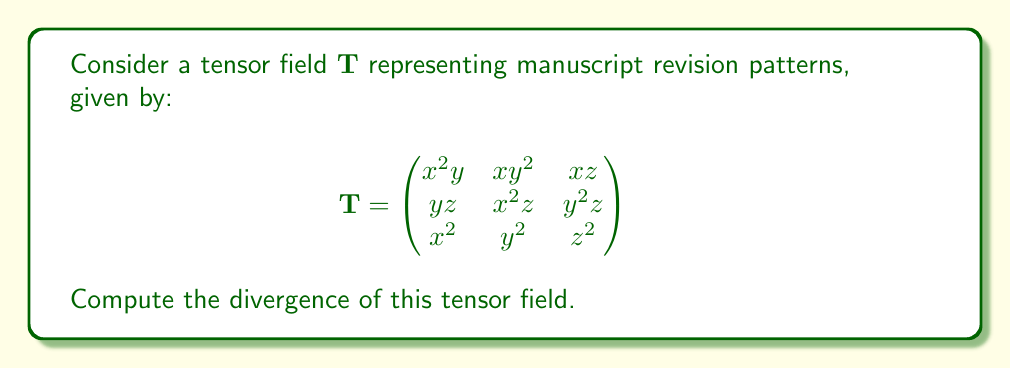Show me your answer to this math problem. To compute the divergence of a tensor field, we need to sum the partial derivatives of the diagonal elements with respect to their corresponding variables.

1) First, let's identify the diagonal elements:
   $T_{11} = x^2y$
   $T_{22} = x^2z$
   $T_{33} = z^2$

2) Now, we'll take the partial derivatives:

   $\frac{\partial T_{11}}{\partial x} = \frac{\partial}{\partial x}(x^2y) = 2xy$

   $\frac{\partial T_{22}}{\partial y} = \frac{\partial}{\partial y}(x^2z) = 0$

   $\frac{\partial T_{33}}{\partial z} = \frac{\partial}{\partial z}(z^2) = 2z$

3) The divergence is the sum of these partial derivatives:

   $\text{div}(\mathbf{T}) = \frac{\partial T_{11}}{\partial x} + \frac{\partial T_{22}}{\partial y} + \frac{\partial T_{33}}{\partial z}$

   $\text{div}(\mathbf{T}) = 2xy + 0 + 2z$

4) Simplifying:

   $\text{div}(\mathbf{T}) = 2xy + 2z$

This result represents the rate at which the manuscript revision pattern is changing at each point in the three-dimensional space of the manuscript (x, y, z).
Answer: $2xy + 2z$ 